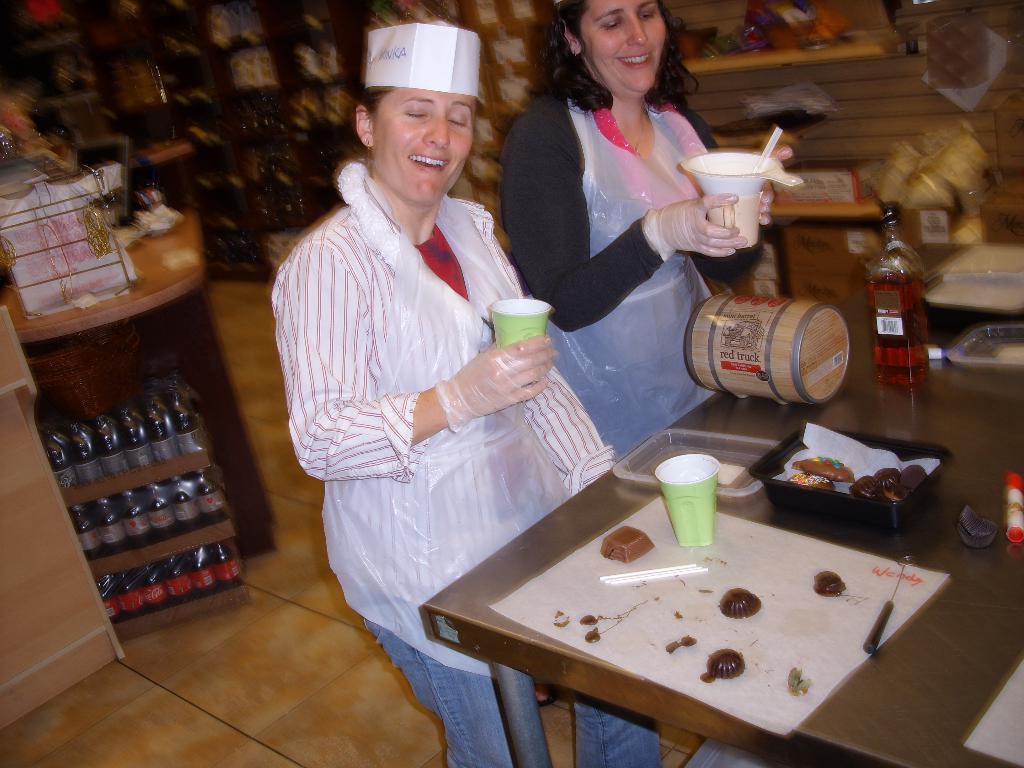In one or two sentences, can you explain what this image depicts? In this image I can see two women and both of them are holding cups. I can also see smile on their faces. On this table I can see a bottle and a cup. In the background I can see number of bottles. 